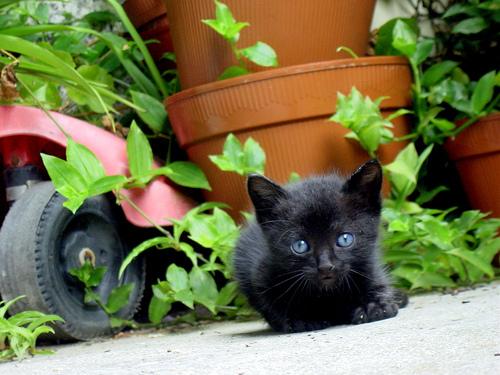What is the color of the cat's eyes?
Write a very short answer. Blue. Is this the same type of feline that was featured in 'The Lion King'?
Be succinct. No. How many pots can be seen?
Be succinct. 3. 